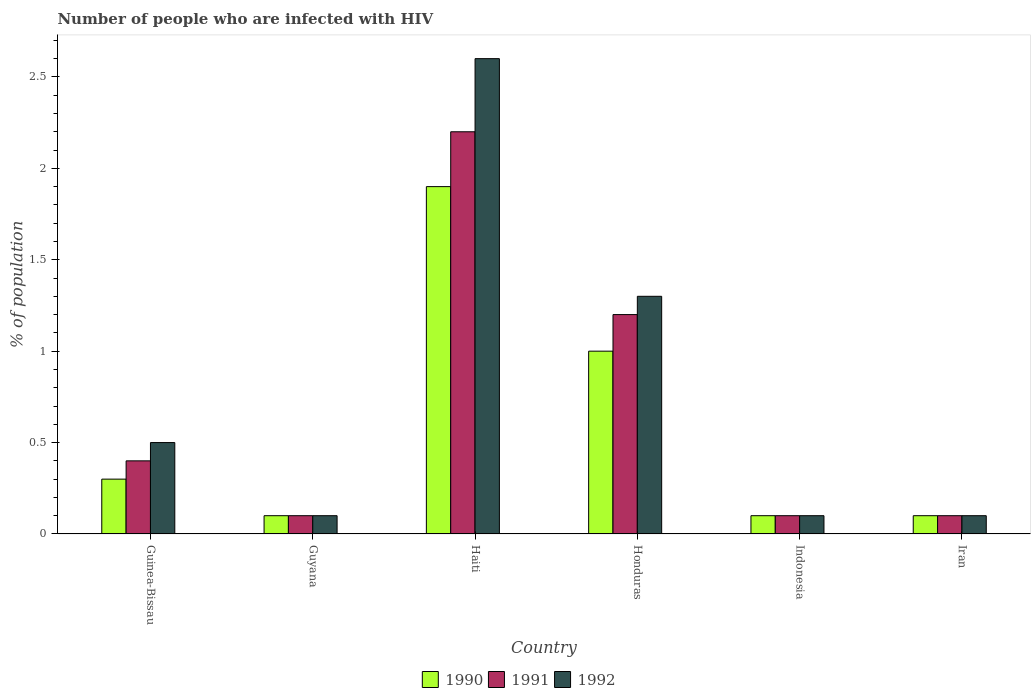Are the number of bars per tick equal to the number of legend labels?
Keep it short and to the point. Yes. How many bars are there on the 5th tick from the right?
Keep it short and to the point. 3. What is the label of the 2nd group of bars from the left?
Your answer should be compact. Guyana. In how many cases, is the number of bars for a given country not equal to the number of legend labels?
Keep it short and to the point. 0. What is the percentage of HIV infected population in in 1991 in Haiti?
Offer a terse response. 2.2. Across all countries, what is the maximum percentage of HIV infected population in in 1990?
Your answer should be very brief. 1.9. Across all countries, what is the minimum percentage of HIV infected population in in 1991?
Keep it short and to the point. 0.1. In which country was the percentage of HIV infected population in in 1992 maximum?
Give a very brief answer. Haiti. In which country was the percentage of HIV infected population in in 1990 minimum?
Provide a succinct answer. Guyana. What is the total percentage of HIV infected population in in 1990 in the graph?
Give a very brief answer. 3.5. What is the difference between the percentage of HIV infected population in in 1991 in Guinea-Bissau and that in Honduras?
Make the answer very short. -0.8. What is the difference between the percentage of HIV infected population in in 1992 in Guinea-Bissau and the percentage of HIV infected population in in 1991 in Honduras?
Your response must be concise. -0.7. What is the average percentage of HIV infected population in in 1991 per country?
Your answer should be very brief. 0.68. What is the difference between the percentage of HIV infected population in of/in 1992 and percentage of HIV infected population in of/in 1991 in Guinea-Bissau?
Your answer should be compact. 0.1. In how many countries, is the percentage of HIV infected population in in 1990 greater than 0.5 %?
Offer a very short reply. 2. Is the percentage of HIV infected population in in 1992 in Guinea-Bissau less than that in Haiti?
Offer a very short reply. Yes. What is the difference between the highest and the second highest percentage of HIV infected population in in 1991?
Your answer should be very brief. -0.8. In how many countries, is the percentage of HIV infected population in in 1992 greater than the average percentage of HIV infected population in in 1992 taken over all countries?
Ensure brevity in your answer.  2. What does the 2nd bar from the left in Honduras represents?
Your answer should be compact. 1991. What is the difference between two consecutive major ticks on the Y-axis?
Provide a succinct answer. 0.5. Are the values on the major ticks of Y-axis written in scientific E-notation?
Make the answer very short. No. Does the graph contain any zero values?
Offer a very short reply. No. Where does the legend appear in the graph?
Your answer should be very brief. Bottom center. How many legend labels are there?
Keep it short and to the point. 3. How are the legend labels stacked?
Your response must be concise. Horizontal. What is the title of the graph?
Keep it short and to the point. Number of people who are infected with HIV. Does "1962" appear as one of the legend labels in the graph?
Give a very brief answer. No. What is the label or title of the X-axis?
Ensure brevity in your answer.  Country. What is the label or title of the Y-axis?
Make the answer very short. % of population. What is the % of population in 1991 in Guinea-Bissau?
Offer a terse response. 0.4. What is the % of population in 1992 in Guinea-Bissau?
Make the answer very short. 0.5. What is the % of population in 1990 in Guyana?
Make the answer very short. 0.1. What is the % of population of 1991 in Haiti?
Provide a short and direct response. 2.2. What is the % of population in 1992 in Haiti?
Your answer should be very brief. 2.6. What is the % of population of 1991 in Honduras?
Give a very brief answer. 1.2. What is the % of population in 1992 in Honduras?
Provide a short and direct response. 1.3. What is the % of population of 1991 in Indonesia?
Provide a short and direct response. 0.1. What is the % of population of 1990 in Iran?
Ensure brevity in your answer.  0.1. Across all countries, what is the maximum % of population in 1990?
Your response must be concise. 1.9. Across all countries, what is the maximum % of population of 1992?
Provide a short and direct response. 2.6. Across all countries, what is the minimum % of population of 1990?
Provide a succinct answer. 0.1. What is the difference between the % of population of 1990 in Guinea-Bissau and that in Guyana?
Make the answer very short. 0.2. What is the difference between the % of population in 1992 in Guinea-Bissau and that in Guyana?
Provide a succinct answer. 0.4. What is the difference between the % of population of 1991 in Guinea-Bissau and that in Honduras?
Your answer should be very brief. -0.8. What is the difference between the % of population of 1992 in Guinea-Bissau and that in Honduras?
Your answer should be very brief. -0.8. What is the difference between the % of population in 1991 in Guinea-Bissau and that in Iran?
Your response must be concise. 0.3. What is the difference between the % of population in 1992 in Guinea-Bissau and that in Iran?
Offer a very short reply. 0.4. What is the difference between the % of population of 1992 in Guyana and that in Haiti?
Your answer should be very brief. -2.5. What is the difference between the % of population of 1990 in Guyana and that in Honduras?
Your response must be concise. -0.9. What is the difference between the % of population of 1992 in Guyana and that in Honduras?
Give a very brief answer. -1.2. What is the difference between the % of population in 1991 in Guyana and that in Indonesia?
Your answer should be compact. 0. What is the difference between the % of population of 1992 in Guyana and that in Indonesia?
Provide a succinct answer. 0. What is the difference between the % of population of 1990 in Guyana and that in Iran?
Your answer should be compact. 0. What is the difference between the % of population of 1991 in Guyana and that in Iran?
Your response must be concise. 0. What is the difference between the % of population in 1991 in Haiti and that in Honduras?
Keep it short and to the point. 1. What is the difference between the % of population of 1992 in Haiti and that in Honduras?
Your answer should be very brief. 1.3. What is the difference between the % of population in 1991 in Haiti and that in Indonesia?
Make the answer very short. 2.1. What is the difference between the % of population of 1990 in Haiti and that in Iran?
Provide a short and direct response. 1.8. What is the difference between the % of population of 1992 in Honduras and that in Iran?
Provide a succinct answer. 1.2. What is the difference between the % of population in 1990 in Indonesia and that in Iran?
Offer a terse response. 0. What is the difference between the % of population in 1991 in Indonesia and that in Iran?
Provide a short and direct response. 0. What is the difference between the % of population of 1992 in Indonesia and that in Iran?
Offer a terse response. 0. What is the difference between the % of population of 1990 in Guinea-Bissau and the % of population of 1992 in Haiti?
Ensure brevity in your answer.  -2.3. What is the difference between the % of population in 1991 in Guinea-Bissau and the % of population in 1992 in Honduras?
Your answer should be very brief. -0.9. What is the difference between the % of population in 1990 in Guinea-Bissau and the % of population in 1991 in Indonesia?
Provide a short and direct response. 0.2. What is the difference between the % of population of 1991 in Guinea-Bissau and the % of population of 1992 in Indonesia?
Your answer should be very brief. 0.3. What is the difference between the % of population in 1990 in Guinea-Bissau and the % of population in 1991 in Iran?
Your answer should be compact. 0.2. What is the difference between the % of population in 1990 in Guyana and the % of population in 1991 in Honduras?
Keep it short and to the point. -1.1. What is the difference between the % of population in 1991 in Guyana and the % of population in 1992 in Honduras?
Ensure brevity in your answer.  -1.2. What is the difference between the % of population of 1990 in Guyana and the % of population of 1991 in Indonesia?
Offer a very short reply. 0. What is the difference between the % of population in 1990 in Guyana and the % of population in 1992 in Indonesia?
Give a very brief answer. 0. What is the difference between the % of population of 1991 in Guyana and the % of population of 1992 in Indonesia?
Your response must be concise. 0. What is the difference between the % of population in 1990 in Guyana and the % of population in 1992 in Iran?
Provide a short and direct response. 0. What is the difference between the % of population of 1990 in Haiti and the % of population of 1991 in Honduras?
Offer a very short reply. 0.7. What is the difference between the % of population of 1991 in Haiti and the % of population of 1992 in Indonesia?
Keep it short and to the point. 2.1. What is the difference between the % of population of 1990 in Haiti and the % of population of 1992 in Iran?
Ensure brevity in your answer.  1.8. What is the difference between the % of population in 1991 in Haiti and the % of population in 1992 in Iran?
Ensure brevity in your answer.  2.1. What is the difference between the % of population in 1990 in Honduras and the % of population in 1991 in Indonesia?
Keep it short and to the point. 0.9. What is the difference between the % of population in 1990 in Honduras and the % of population in 1992 in Indonesia?
Your answer should be compact. 0.9. What is the difference between the % of population of 1990 in Honduras and the % of population of 1992 in Iran?
Ensure brevity in your answer.  0.9. What is the difference between the % of population in 1991 in Honduras and the % of population in 1992 in Iran?
Provide a succinct answer. 1.1. What is the difference between the % of population in 1990 in Indonesia and the % of population in 1992 in Iran?
Provide a succinct answer. 0. What is the average % of population in 1990 per country?
Offer a very short reply. 0.58. What is the average % of population of 1991 per country?
Keep it short and to the point. 0.68. What is the average % of population of 1992 per country?
Your response must be concise. 0.78. What is the difference between the % of population of 1990 and % of population of 1991 in Guinea-Bissau?
Your answer should be compact. -0.1. What is the difference between the % of population in 1990 and % of population in 1992 in Guinea-Bissau?
Keep it short and to the point. -0.2. What is the difference between the % of population of 1990 and % of population of 1992 in Haiti?
Offer a terse response. -0.7. What is the difference between the % of population in 1990 and % of population in 1992 in Honduras?
Your answer should be compact. -0.3. What is the difference between the % of population in 1991 and % of population in 1992 in Honduras?
Ensure brevity in your answer.  -0.1. What is the difference between the % of population of 1990 and % of population of 1991 in Iran?
Offer a terse response. 0. What is the difference between the % of population of 1990 and % of population of 1992 in Iran?
Give a very brief answer. 0. What is the ratio of the % of population in 1990 in Guinea-Bissau to that in Guyana?
Your answer should be very brief. 3. What is the ratio of the % of population of 1991 in Guinea-Bissau to that in Guyana?
Provide a short and direct response. 4. What is the ratio of the % of population of 1990 in Guinea-Bissau to that in Haiti?
Provide a short and direct response. 0.16. What is the ratio of the % of population in 1991 in Guinea-Bissau to that in Haiti?
Your response must be concise. 0.18. What is the ratio of the % of population of 1992 in Guinea-Bissau to that in Haiti?
Give a very brief answer. 0.19. What is the ratio of the % of population of 1990 in Guinea-Bissau to that in Honduras?
Offer a terse response. 0.3. What is the ratio of the % of population in 1991 in Guinea-Bissau to that in Honduras?
Your response must be concise. 0.33. What is the ratio of the % of population of 1992 in Guinea-Bissau to that in Honduras?
Keep it short and to the point. 0.38. What is the ratio of the % of population of 1990 in Guinea-Bissau to that in Iran?
Provide a short and direct response. 3. What is the ratio of the % of population of 1991 in Guinea-Bissau to that in Iran?
Make the answer very short. 4. What is the ratio of the % of population of 1990 in Guyana to that in Haiti?
Provide a short and direct response. 0.05. What is the ratio of the % of population of 1991 in Guyana to that in Haiti?
Give a very brief answer. 0.05. What is the ratio of the % of population of 1992 in Guyana to that in Haiti?
Provide a short and direct response. 0.04. What is the ratio of the % of population of 1991 in Guyana to that in Honduras?
Offer a very short reply. 0.08. What is the ratio of the % of population in 1992 in Guyana to that in Honduras?
Offer a terse response. 0.08. What is the ratio of the % of population of 1990 in Guyana to that in Indonesia?
Offer a very short reply. 1. What is the ratio of the % of population of 1991 in Guyana to that in Indonesia?
Offer a terse response. 1. What is the ratio of the % of population in 1991 in Guyana to that in Iran?
Make the answer very short. 1. What is the ratio of the % of population of 1992 in Guyana to that in Iran?
Offer a very short reply. 1. What is the ratio of the % of population of 1990 in Haiti to that in Honduras?
Give a very brief answer. 1.9. What is the ratio of the % of population in 1991 in Haiti to that in Honduras?
Make the answer very short. 1.83. What is the ratio of the % of population of 1992 in Haiti to that in Honduras?
Offer a very short reply. 2. What is the ratio of the % of population of 1990 in Haiti to that in Indonesia?
Give a very brief answer. 19. What is the ratio of the % of population of 1991 in Haiti to that in Indonesia?
Keep it short and to the point. 22. What is the ratio of the % of population of 1992 in Haiti to that in Indonesia?
Make the answer very short. 26. What is the ratio of the % of population of 1991 in Haiti to that in Iran?
Provide a short and direct response. 22. What is the ratio of the % of population of 1990 in Honduras to that in Indonesia?
Make the answer very short. 10. What is the ratio of the % of population in 1992 in Honduras to that in Indonesia?
Your answer should be compact. 13. What is the ratio of the % of population of 1991 in Honduras to that in Iran?
Offer a very short reply. 12. What is the ratio of the % of population in 1992 in Honduras to that in Iran?
Your response must be concise. 13. What is the ratio of the % of population of 1991 in Indonesia to that in Iran?
Your answer should be very brief. 1. What is the difference between the highest and the second highest % of population in 1990?
Ensure brevity in your answer.  0.9. What is the difference between the highest and the second highest % of population of 1991?
Your answer should be compact. 1. What is the difference between the highest and the lowest % of population of 1991?
Make the answer very short. 2.1. What is the difference between the highest and the lowest % of population of 1992?
Offer a very short reply. 2.5. 